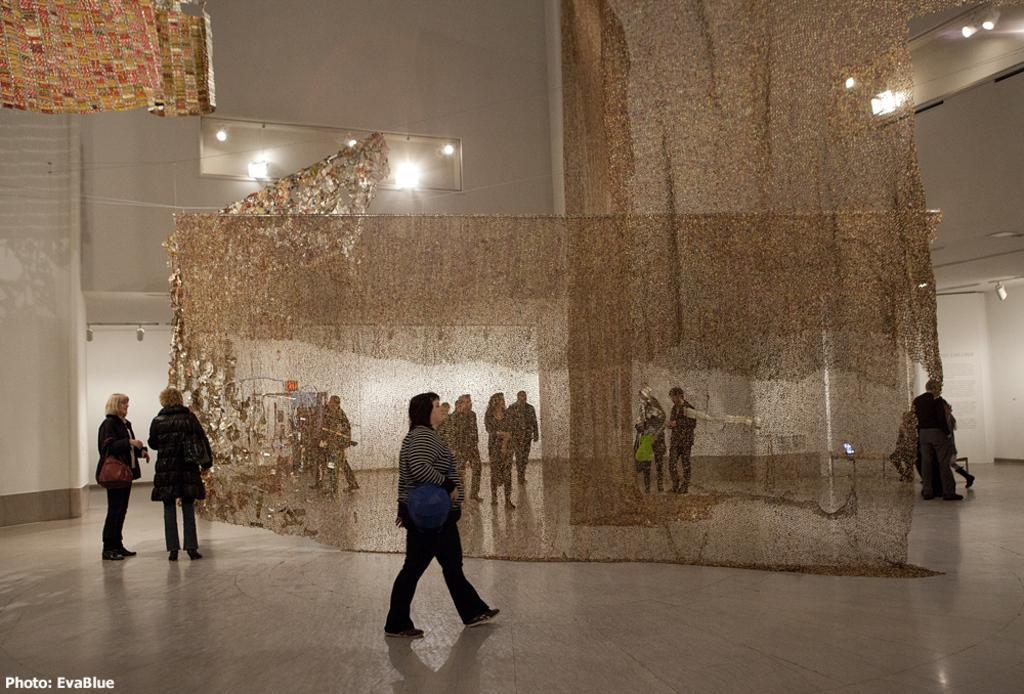Describe this image in one or two sentences. There are people, it seems like curtains in the foreground area of the image, there are lamps and people in the background. 